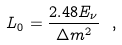Convert formula to latex. <formula><loc_0><loc_0><loc_500><loc_500>L _ { 0 } = \frac { 2 . 4 8 E _ { \nu } } { \Delta m ^ { 2 } } \ ,</formula> 